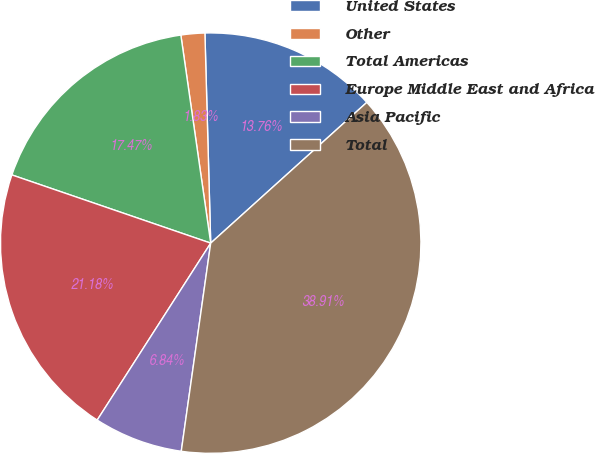Convert chart. <chart><loc_0><loc_0><loc_500><loc_500><pie_chart><fcel>United States<fcel>Other<fcel>Total Americas<fcel>Europe Middle East and Africa<fcel>Asia Pacific<fcel>Total<nl><fcel>13.76%<fcel>1.83%<fcel>17.47%<fcel>21.18%<fcel>6.84%<fcel>38.91%<nl></chart> 